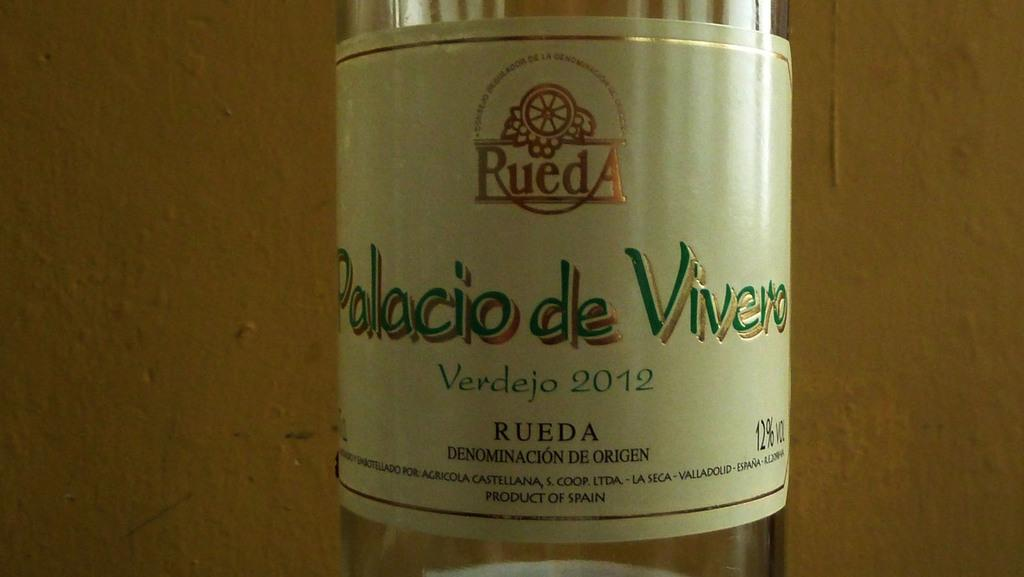What object can be seen in the image that is made of glass? There is a glass bottle in the image. What is on the surface of the glass bottle? The glass bottle has a label on it. What type of leather is being used to cover the ground in the image? There is no leather or ground visible in the image; it only features a glass bottle with a label on it. 